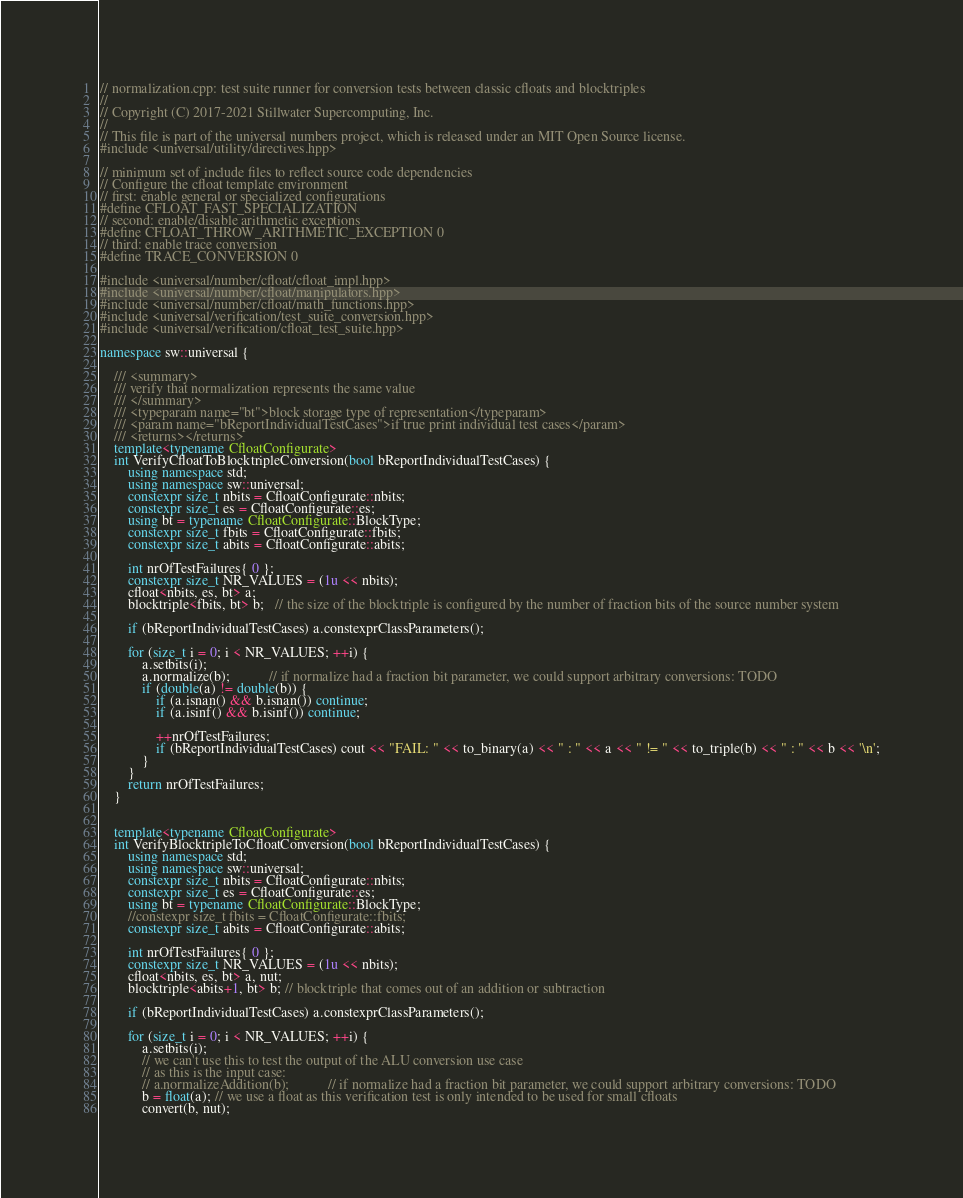<code> <loc_0><loc_0><loc_500><loc_500><_C++_>// normalization.cpp: test suite runner for conversion tests between classic cfloats and blocktriples
//
// Copyright (C) 2017-2021 Stillwater Supercomputing, Inc.
//
// This file is part of the universal numbers project, which is released under an MIT Open Source license.
#include <universal/utility/directives.hpp>

// minimum set of include files to reflect source code dependencies
// Configure the cfloat template environment
// first: enable general or specialized configurations
#define CFLOAT_FAST_SPECIALIZATION
// second: enable/disable arithmetic exceptions
#define CFLOAT_THROW_ARITHMETIC_EXCEPTION 0
// third: enable trace conversion
#define TRACE_CONVERSION 0

#include <universal/number/cfloat/cfloat_impl.hpp>
#include <universal/number/cfloat/manipulators.hpp>
#include <universal/number/cfloat/math_functions.hpp>
#include <universal/verification/test_suite_conversion.hpp>
#include <universal/verification/cfloat_test_suite.hpp>

namespace sw::universal {

	/// <summary>
	/// verify that normalization represents the same value
	/// </summary>
	/// <typeparam name="bt">block storage type of representation</typeparam>
	/// <param name="bReportIndividualTestCases">if true print individual test cases</param>
	/// <returns></returns>
	template<typename CfloatConfigurate>
	int VerifyCfloatToBlocktripleConversion(bool bReportIndividualTestCases) {
		using namespace std;
		using namespace sw::universal;
		constexpr size_t nbits = CfloatConfigurate::nbits;
		constexpr size_t es = CfloatConfigurate::es;
		using bt = typename CfloatConfigurate::BlockType;
		constexpr size_t fbits = CfloatConfigurate::fbits;
		constexpr size_t abits = CfloatConfigurate::abits;

		int nrOfTestFailures{ 0 };
		constexpr size_t NR_VALUES = (1u << nbits);
		cfloat<nbits, es, bt> a;
		blocktriple<fbits, bt> b;   // the size of the blocktriple is configured by the number of fraction bits of the source number system

		if (bReportIndividualTestCases) a.constexprClassParameters();

		for (size_t i = 0; i < NR_VALUES; ++i) {
			a.setbits(i);
			a.normalize(b);           // if normalize had a fraction bit parameter, we could support arbitrary conversions: TODO
			if (double(a) != double(b)) {
				if (a.isnan() && b.isnan()) continue;
				if (a.isinf() && b.isinf()) continue;

				++nrOfTestFailures;
				if (bReportIndividualTestCases) cout << "FAIL: " << to_binary(a) << " : " << a << " != " << to_triple(b) << " : " << b << '\n';
			}
		}
		return nrOfTestFailures;
	}


	template<typename CfloatConfigurate>
	int VerifyBlocktripleToCfloatConversion(bool bReportIndividualTestCases) {
		using namespace std;
		using namespace sw::universal;
		constexpr size_t nbits = CfloatConfigurate::nbits;
		constexpr size_t es = CfloatConfigurate::es;
		using bt = typename CfloatConfigurate::BlockType;
		//constexpr size_t fbits = CfloatConfigurate::fbits;
		constexpr size_t abits = CfloatConfigurate::abits;

		int nrOfTestFailures{ 0 };
		constexpr size_t NR_VALUES = (1u << nbits);
		cfloat<nbits, es, bt> a, nut;
		blocktriple<abits+1, bt> b; // blocktriple that comes out of an addition or subtraction

		if (bReportIndividualTestCases) a.constexprClassParameters();

		for (size_t i = 0; i < NR_VALUES; ++i) {
			a.setbits(i);
			// we can't use this to test the output of the ALU conversion use case
			// as this is the input case:
			// a.normalizeAddition(b);           // if normalize had a fraction bit parameter, we could support arbitrary conversions: TODO
			b = float(a); // we use a float as this verification test is only intended to be used for small cfloats
			convert(b, nut);</code> 